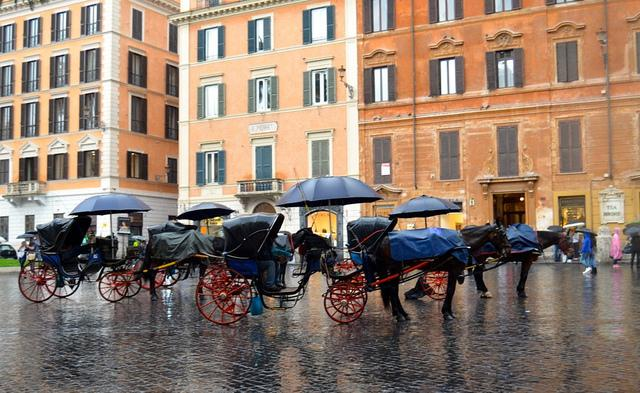What group usually uses this mode of transport? Please explain your reasoning. amish. The amish don't use cars or technology. 